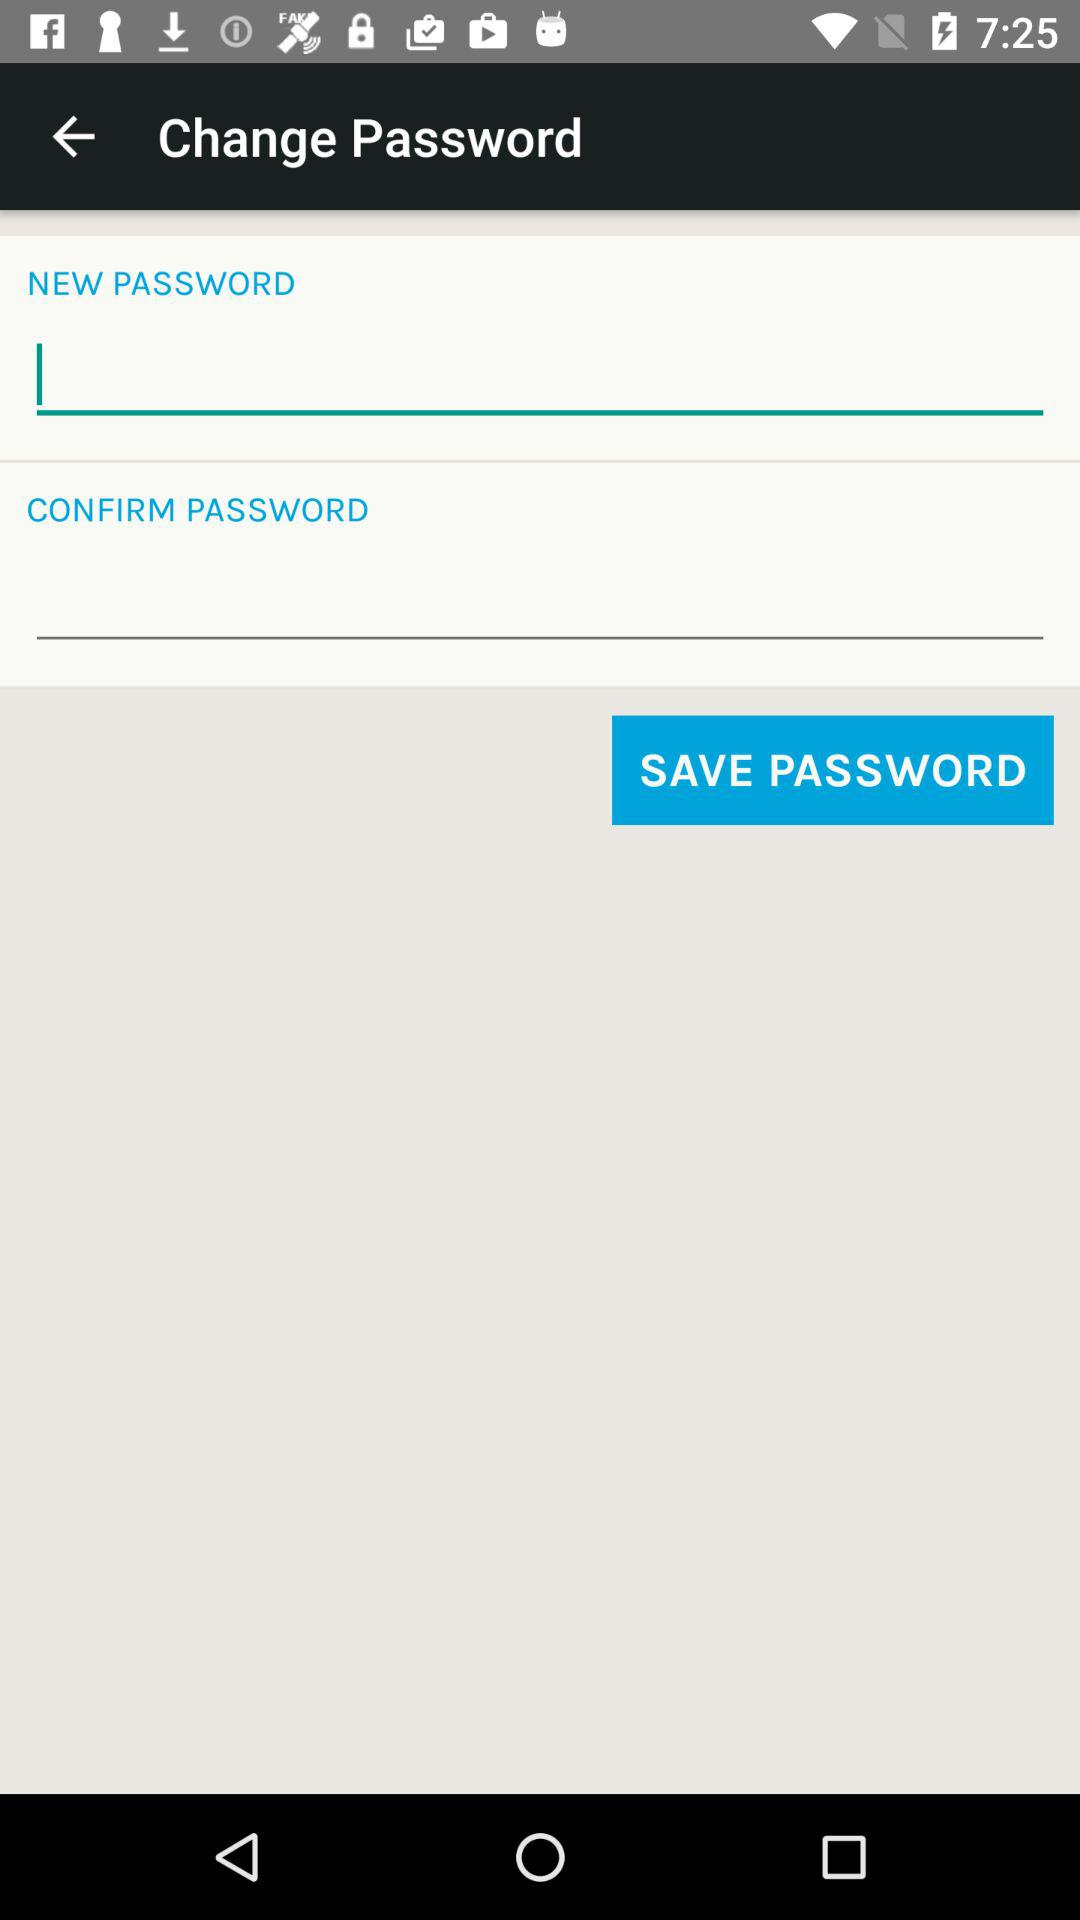How many text inputs are on the screen?
Answer the question using a single word or phrase. 2 